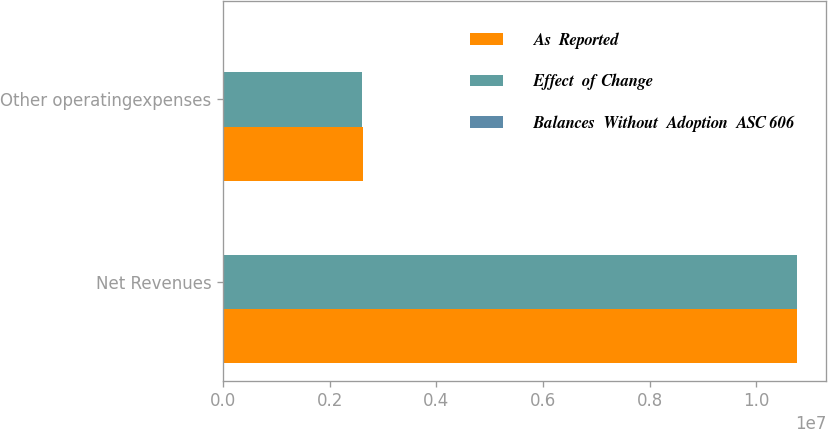Convert chart. <chart><loc_0><loc_0><loc_500><loc_500><stacked_bar_chart><ecel><fcel>Net Revenues<fcel>Other operatingexpenses<nl><fcel>As  Reported<fcel>1.07723e+07<fcel>2.61469e+06<nl><fcel>Effect  of Change<fcel>1.07578e+07<fcel>2.60023e+06<nl><fcel>Balances  Without  Adoption  ASC 606<fcel>14457<fcel>14457<nl></chart> 